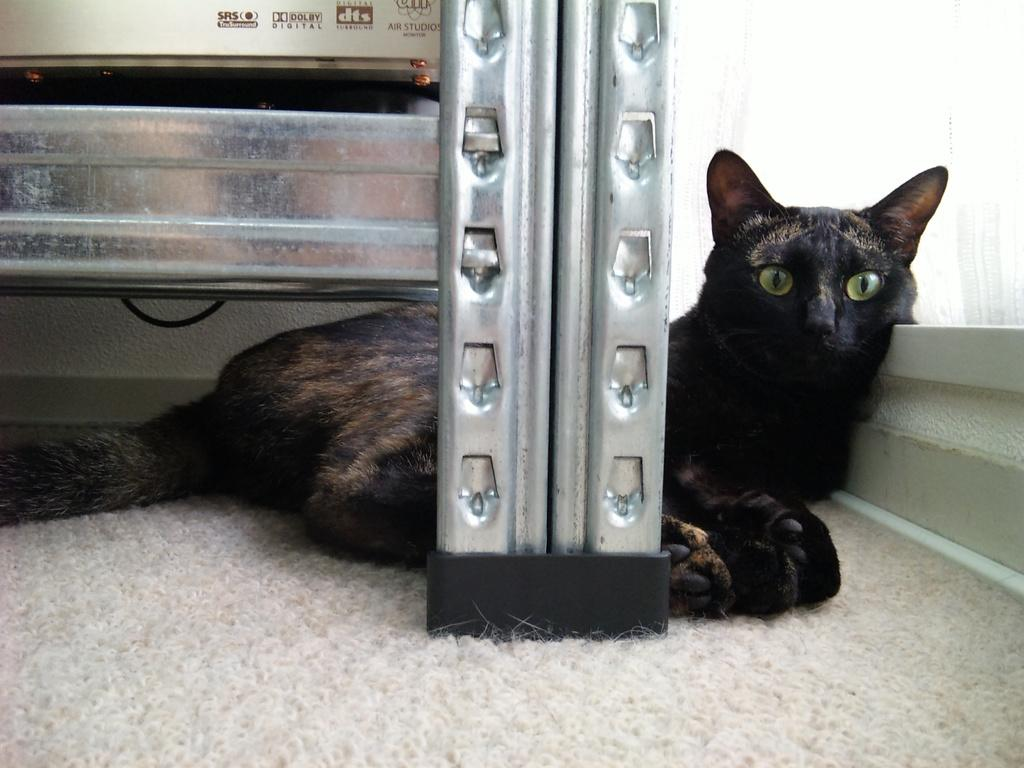What type of animal is present in the image? There is a black cat in the image. What is located at the bottom of the image? There is a floor mat at the bottom of the image. What can be seen in the front of the image? There is a stand in the front of the image. What architectural features are visible to the right of the image? There is a window along with a wall to the right of the image. What type of linen is being used to cover the cat in the image? There is no linen present in the image, and the cat is not covered. What suggestion does the cat have for the viewer in the image? The image does not convey any suggestions from the cat, as it is a static representation. 